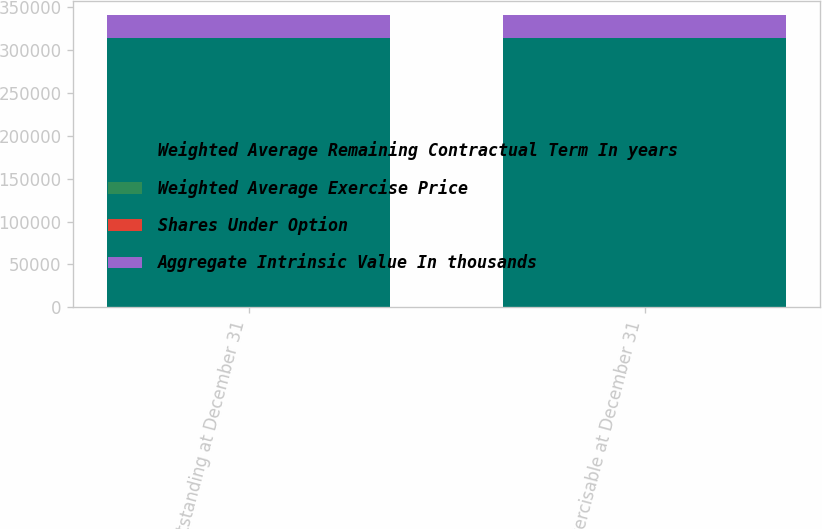Convert chart. <chart><loc_0><loc_0><loc_500><loc_500><stacked_bar_chart><ecel><fcel>Outstanding at December 31<fcel>Exercisable at December 31<nl><fcel>Weighted Average Remaining Contractual Term In years<fcel>313802<fcel>313802<nl><fcel>Weighted Average Exercise Price<fcel>60.93<fcel>60.93<nl><fcel>Shares Under Option<fcel>2.5<fcel>2.5<nl><fcel>Aggregate Intrinsic Value In thousands<fcel>26726<fcel>26726<nl></chart> 